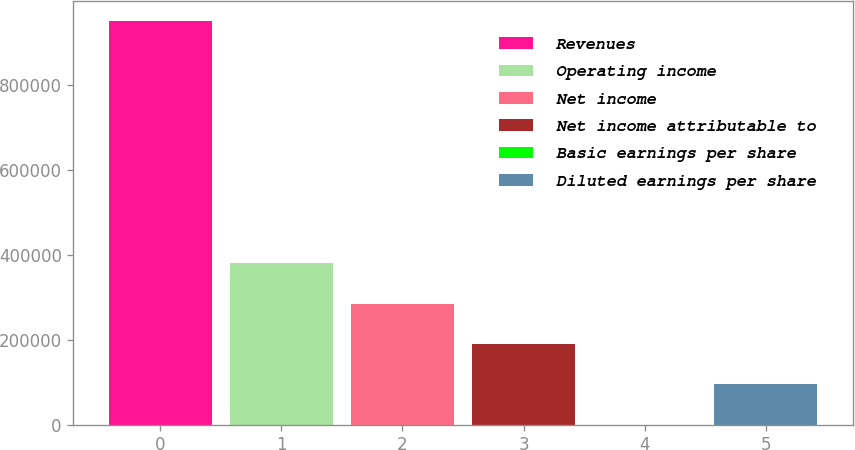Convert chart. <chart><loc_0><loc_0><loc_500><loc_500><bar_chart><fcel>Revenues<fcel>Operating income<fcel>Net income<fcel>Net income attributable to<fcel>Basic earnings per share<fcel>Diluted earnings per share<nl><fcel>950187<fcel>380075<fcel>285056<fcel>190038<fcel>0.16<fcel>95018.8<nl></chart> 